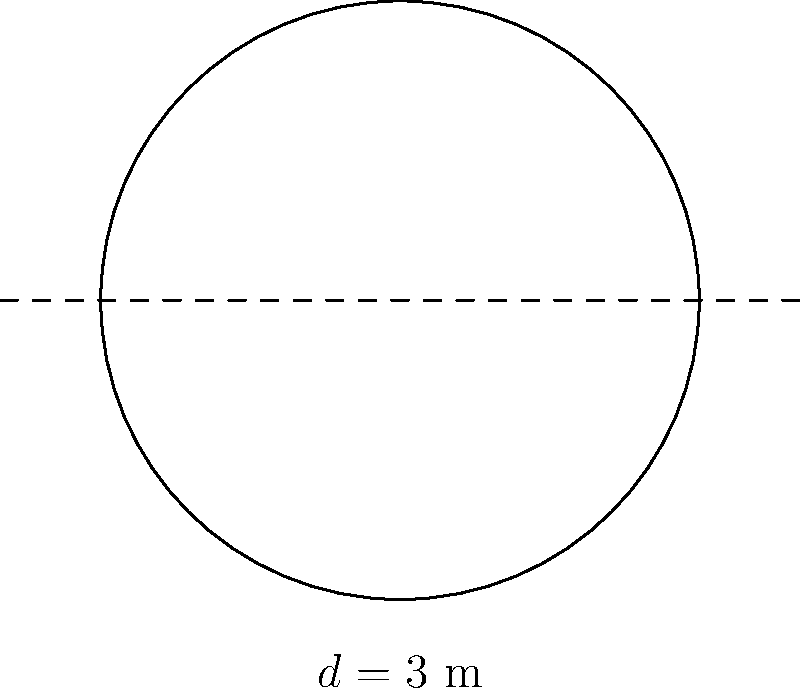In a luxurious Greek restaurant, a circular dining table has a diameter of 3 meters. What is the area of the table's surface in square meters? Round your answer to two decimal places. To find the area of a circular table, we need to follow these steps:

1. Recall the formula for the area of a circle: $A = \pi r^2$, where $r$ is the radius.

2. We are given the diameter $d = 3$ m. The radius is half of the diameter:
   $r = \frac{d}{2} = \frac{3}{2} = 1.5$ m

3. Now we can substitute this into our formula:
   $A = \pi (1.5)^2$

4. Calculate:
   $A = \pi (2.25) \approx 7.0685775$ m²

5. Rounding to two decimal places:
   $A \approx 7.07$ m²
Answer: $7.07$ m² 